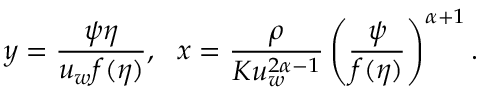<formula> <loc_0><loc_0><loc_500><loc_500>y = \frac { \psi \eta } { u _ { w } f ( \eta ) } , x = \frac { \rho } { K u _ { w } ^ { 2 \alpha - 1 } } \left ( \frac { \psi } { f ( \eta ) } \right ) ^ { \alpha + 1 } .</formula> 